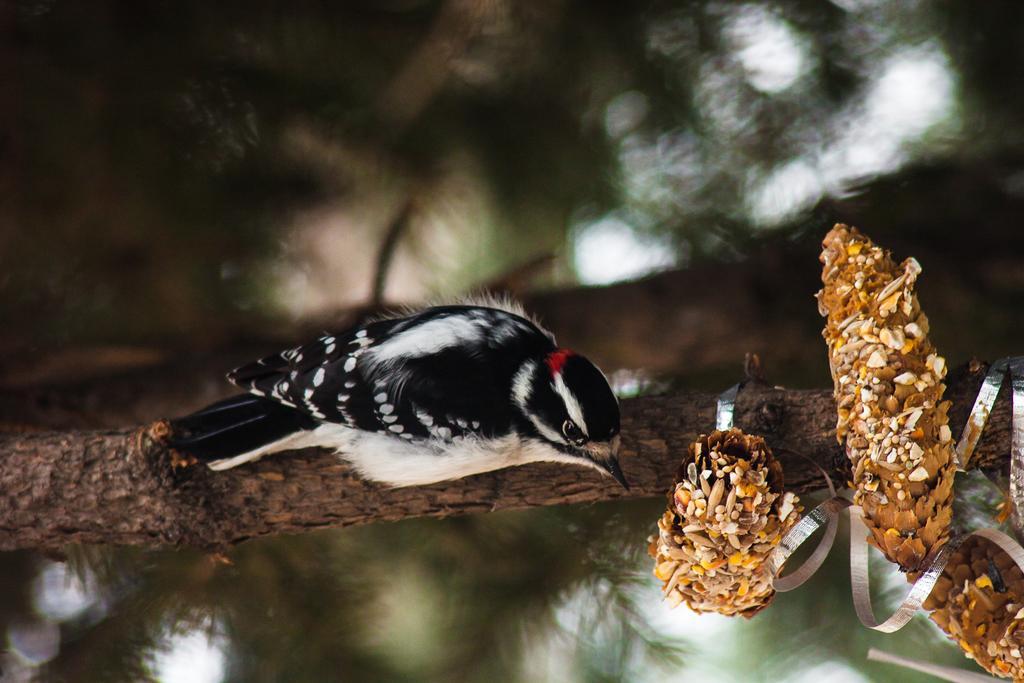How would you summarize this image in a sentence or two? In this image I can see a bird on a stem. I can see the bird in black and white colors. On the right side, I can see some flowers. The background is blurred. 